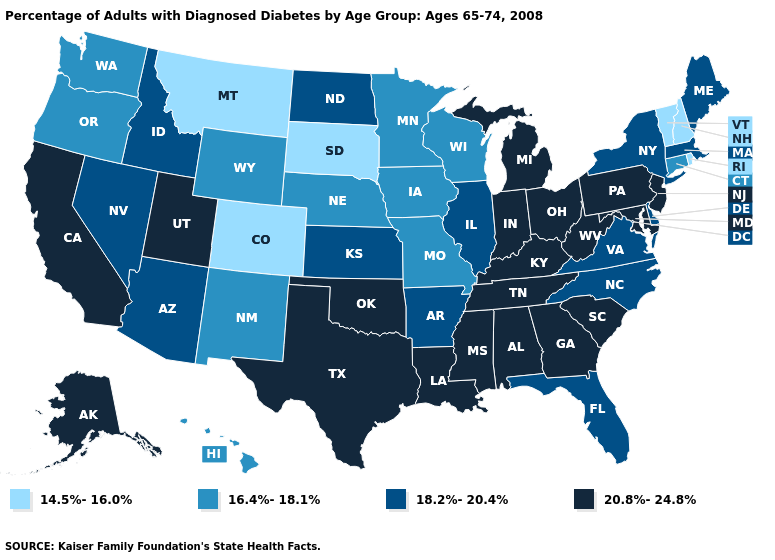What is the value of Arkansas?
Quick response, please. 18.2%-20.4%. Does Colorado have the lowest value in the West?
Concise answer only. Yes. What is the value of Oregon?
Be succinct. 16.4%-18.1%. Name the states that have a value in the range 20.8%-24.8%?
Give a very brief answer. Alabama, Alaska, California, Georgia, Indiana, Kentucky, Louisiana, Maryland, Michigan, Mississippi, New Jersey, Ohio, Oklahoma, Pennsylvania, South Carolina, Tennessee, Texas, Utah, West Virginia. Which states have the lowest value in the USA?
Short answer required. Colorado, Montana, New Hampshire, Rhode Island, South Dakota, Vermont. Does the map have missing data?
Give a very brief answer. No. What is the value of Virginia?
Keep it brief. 18.2%-20.4%. Which states have the lowest value in the USA?
Give a very brief answer. Colorado, Montana, New Hampshire, Rhode Island, South Dakota, Vermont. What is the value of Missouri?
Concise answer only. 16.4%-18.1%. Name the states that have a value in the range 14.5%-16.0%?
Short answer required. Colorado, Montana, New Hampshire, Rhode Island, South Dakota, Vermont. Does Connecticut have the highest value in the USA?
Give a very brief answer. No. What is the value of Delaware?
Give a very brief answer. 18.2%-20.4%. What is the lowest value in the South?
Concise answer only. 18.2%-20.4%. Does South Carolina have the highest value in the USA?
Answer briefly. Yes. Name the states that have a value in the range 16.4%-18.1%?
Answer briefly. Connecticut, Hawaii, Iowa, Minnesota, Missouri, Nebraska, New Mexico, Oregon, Washington, Wisconsin, Wyoming. 